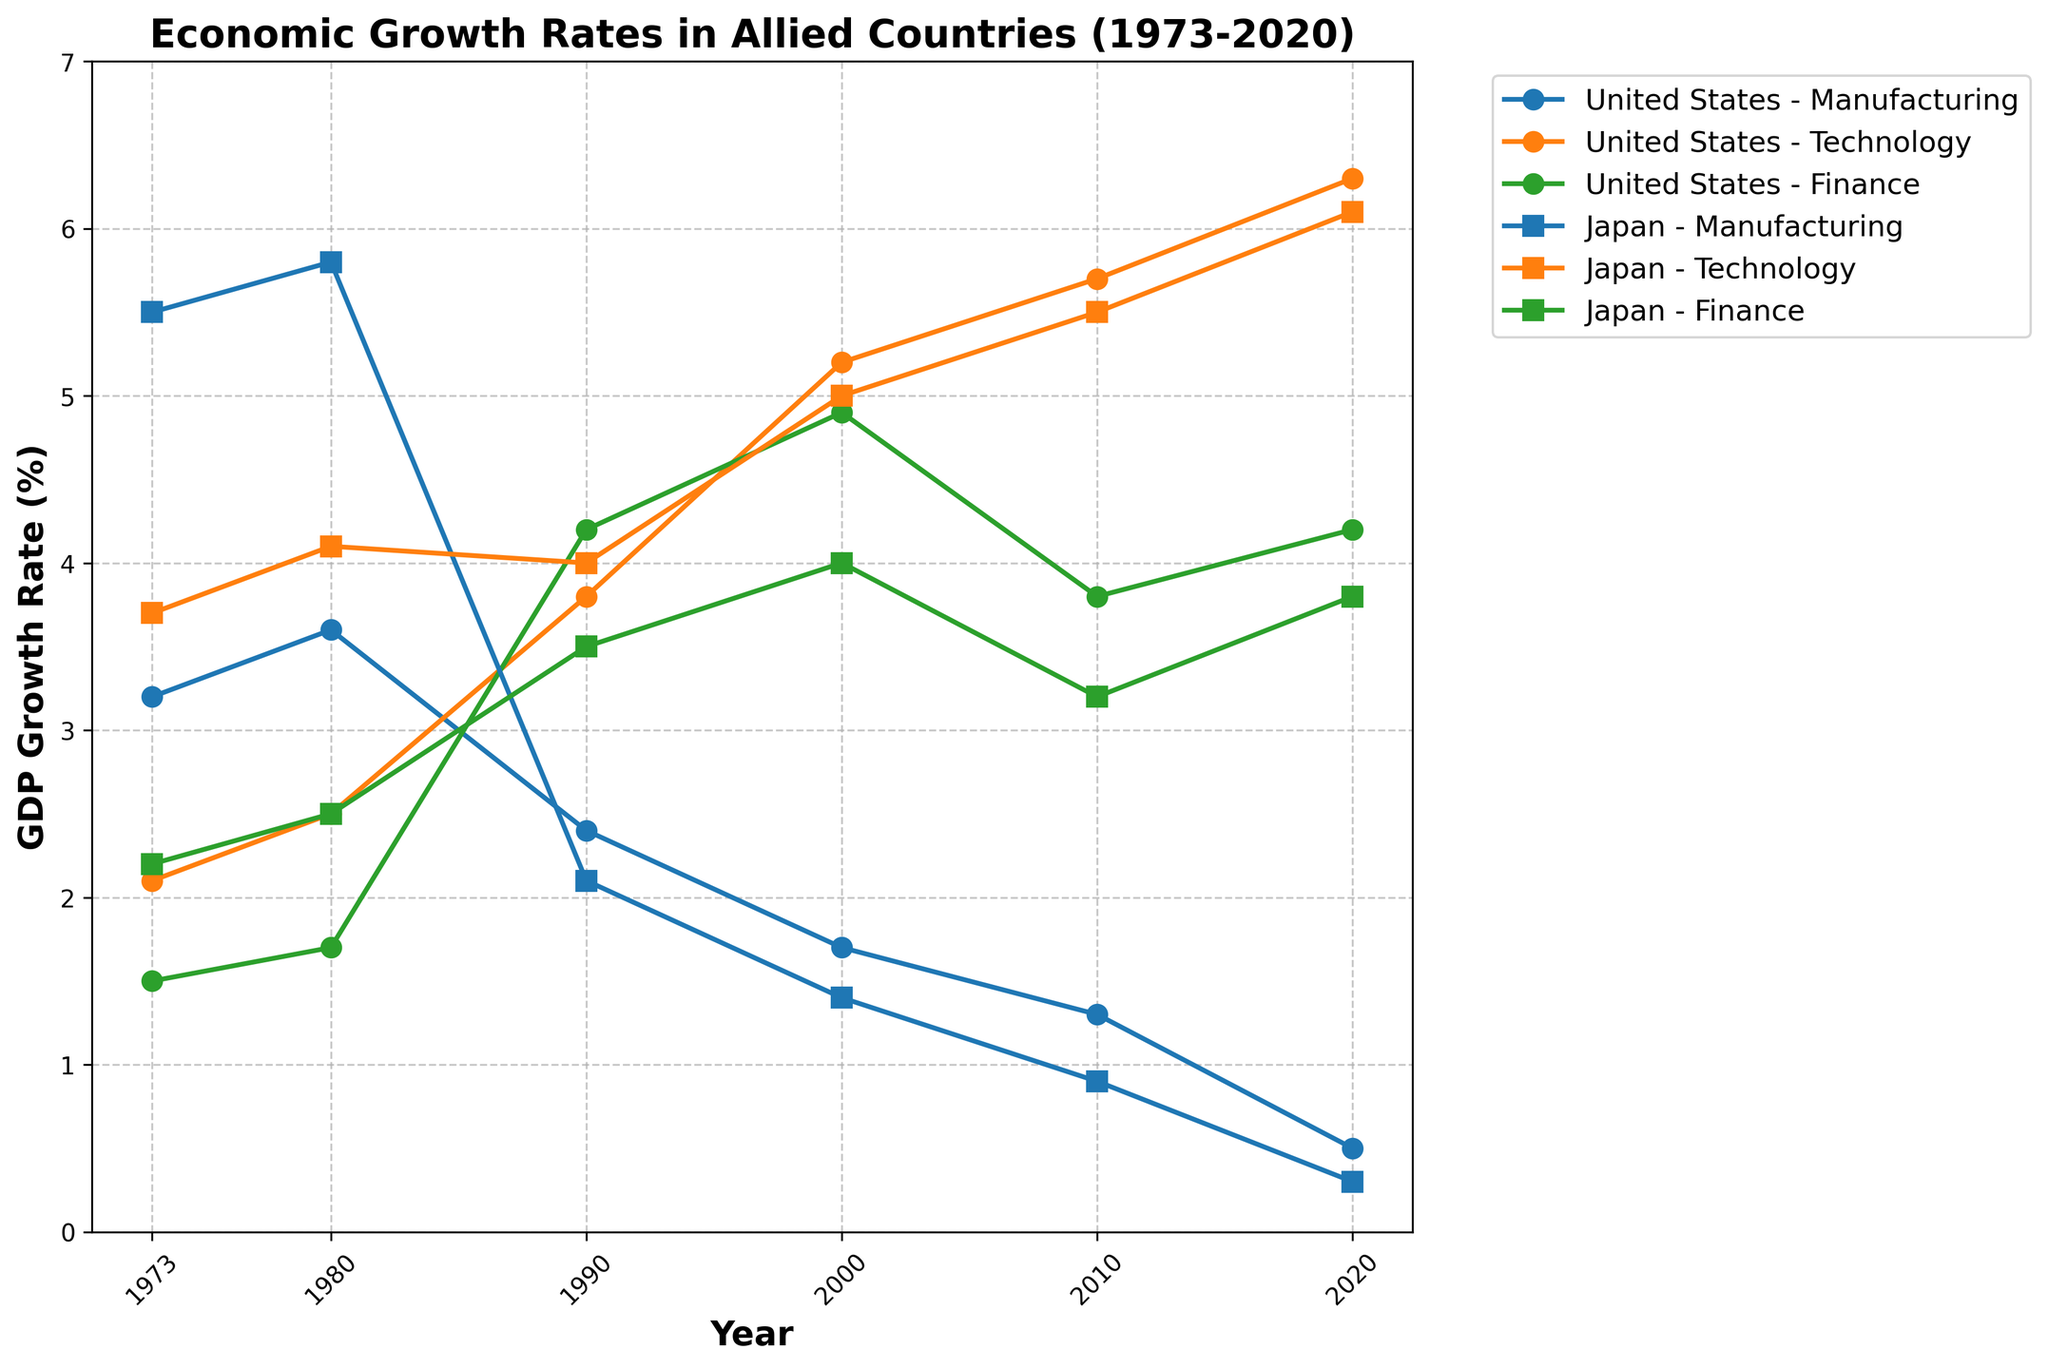What is the title of the figure? The title is prominently displayed at the top of the figure, typically in a larger and bold font. It provides a summary of what is depicted in the plot.
Answer: Economic Growth Rates in Allied Countries (1973-2020) Which industry had the highest GDP growth rate in the United States in 2020? Locate the points along the 2020 axis for the United States and compare the GDP growth rates for each industry.
Answer: Technology What trend can be observed in the Manufacturing sector for Japan from 1973 to 2020? Identify the line corresponding to Japan's Manufacturing sector and observe the changes in GDP growth rates over time. The key points are a consistent decline in the growth rate.
Answer: Consistent decline Compare the GDP growth rates between the Technology sectors of the United States and Japan in 2010. Which country had a higher rate? Find the data points for both countries in the Technology sector for the year 2010 and compare the values.
Answer: United States Did the GDP growth rate in the Finance sector for the United States ever surpass 4% over the period shown? If so, in which years? Look at the points for the United States in the Finance sector across the timeline and identify the points where the growth rate exceeds 4%.
Answer: 1990, 2000, 2020 What was the average GDP growth rate of Japan's Manufacturing sector between 1980 and 2020? Calculate the average by summing the growth rates for Japan's Manufacturing sector from 1980, 1990, 2000, 2010, and 2020 and then divide by the number of data points (5).
Answer: (5.8 + 2.1 + 1.4 + 0.9 + 0.3)/5 = 2.1 Which country saw a steeper increase in the Technology sector's GDP growth rate from 2000 to 2010? Compare the increase in the Technology sector's GDP growth rate from 2000 to 2010 for both countries by calculating the difference for the respective years.
Answer: United States In which year did the GDP growth rate in Japan's Finance sector match the United States' Manufacturing sector? Compare the data points for both countries and industries across the years and identify any matching values.
Answer: 2010 What is the overall trend for the Technology sector for both countries from 1973 to 2020? Observe the lines corresponding to the Technology sector for both the United States and Japan and note the changes over the years. Both lines exhibit a generally upward trend.
Answer: Upward trend 